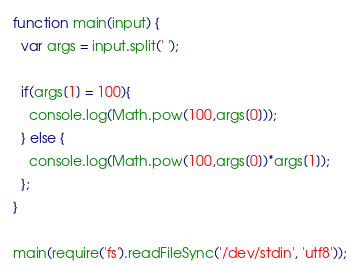Convert code to text. <code><loc_0><loc_0><loc_500><loc_500><_JavaScript_>function main(input) {
  var args = input.split(' ');
  
  if(args[1] = 100){
    console.log(Math.pow(100,args[0]));
  } else {
    console.log(Math.pow(100,args[0])*args[1]);
  };
}
 
main(require('fs').readFileSync('/dev/stdin', 'utf8'));</code> 